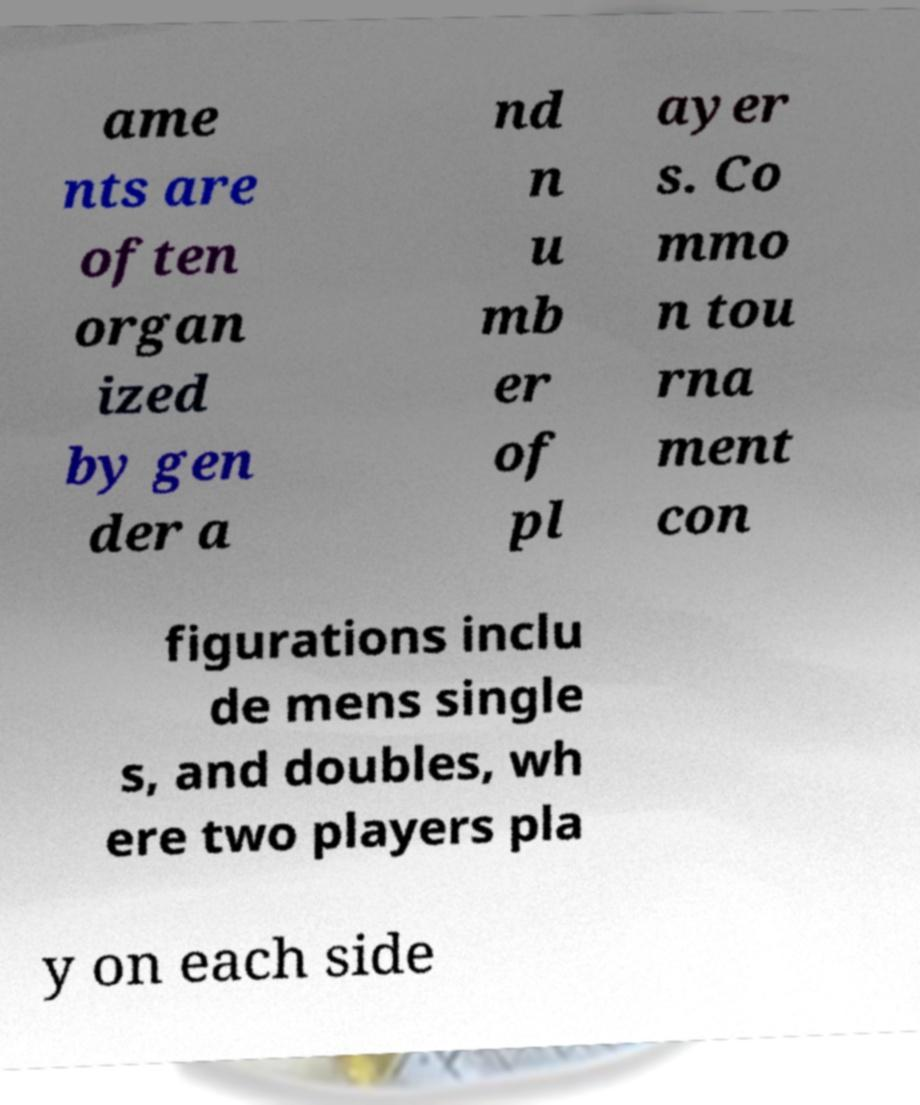Please read and relay the text visible in this image. What does it say? ame nts are often organ ized by gen der a nd n u mb er of pl ayer s. Co mmo n tou rna ment con figurations inclu de mens single s, and doubles, wh ere two players pla y on each side 